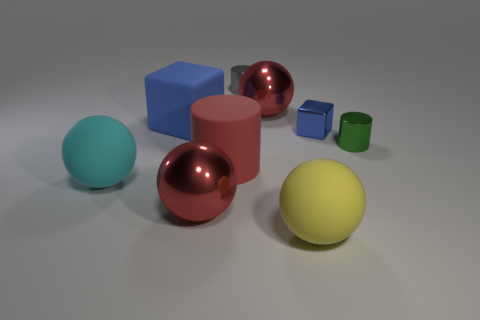Are the small blue block and the block on the left side of the gray metallic cylinder made of the same material?
Make the answer very short. No. What is the material of the cylinder that is on the right side of the large yellow rubber thing?
Provide a short and direct response. Metal. What number of other objects are there of the same shape as the large cyan matte thing?
Provide a succinct answer. 3. There is a metallic object that is left of the gray cylinder; is its shape the same as the green metal thing?
Ensure brevity in your answer.  No. There is a blue shiny object; are there any tiny green metallic objects left of it?
Provide a short and direct response. No. How many big things are either green cylinders or blue metallic blocks?
Ensure brevity in your answer.  0. Do the big yellow thing and the cyan object have the same material?
Your answer should be compact. Yes. There is another metallic cube that is the same color as the large block; what size is it?
Your answer should be very brief. Small. Are there any large shiny objects of the same color as the big cylinder?
Your response must be concise. Yes. What size is the cylinder that is made of the same material as the big blue block?
Make the answer very short. Large. 